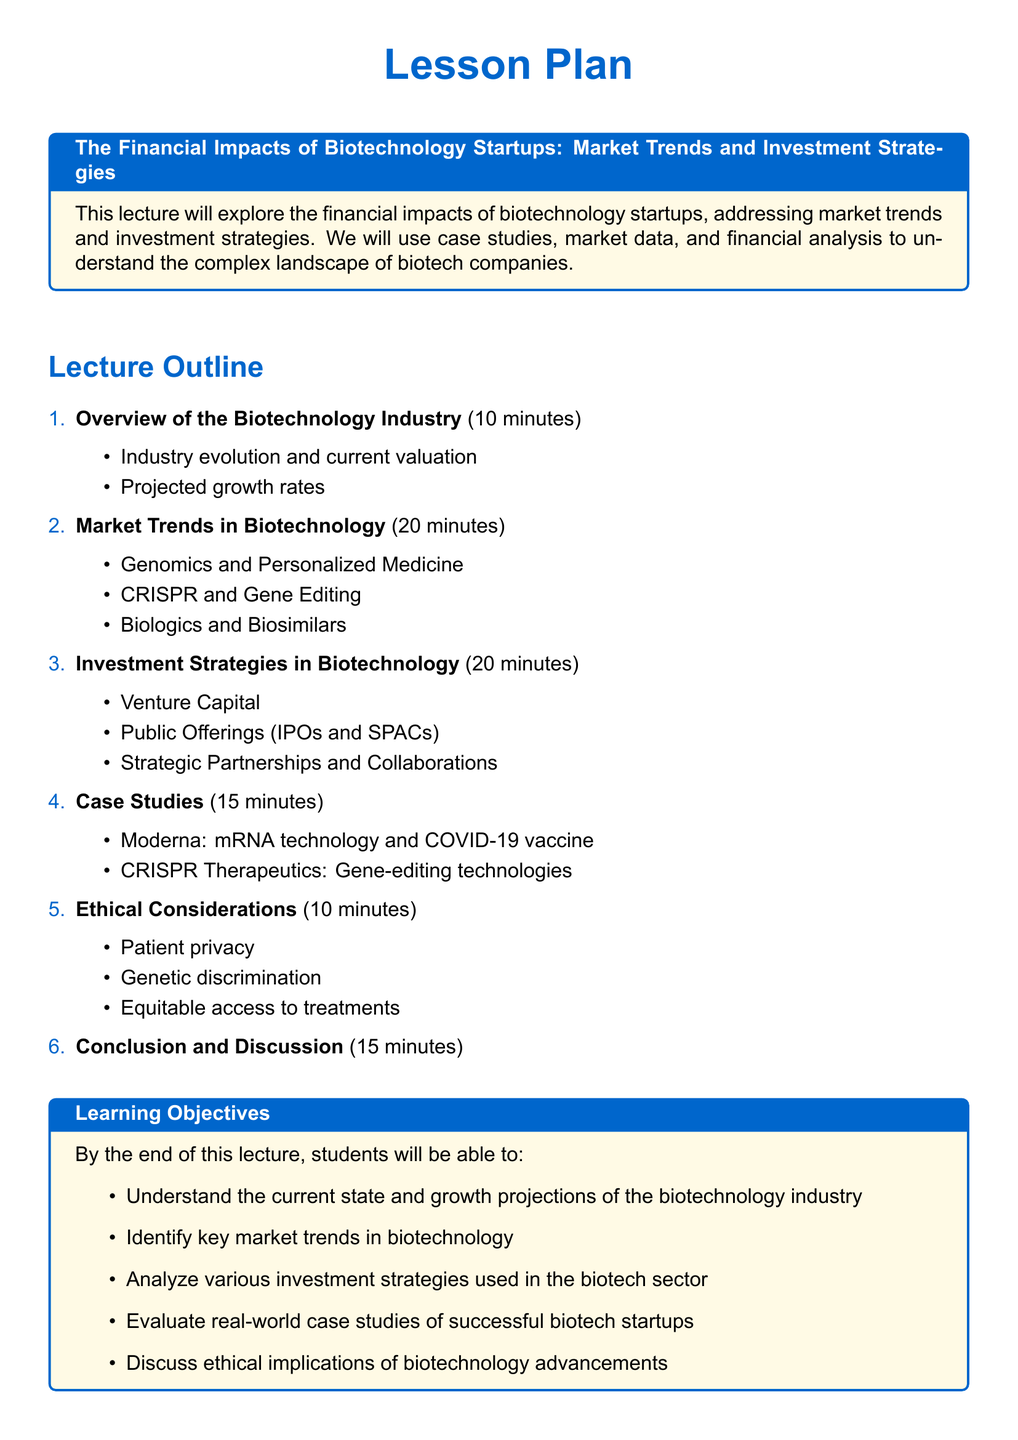What is the total duration of the lecture? The total duration is calculated by adding all the time allocations for each section of the lecture, which totals 90 minutes.
Answer: 90 minutes What is one of the key market trends discussed in the lecture? The lecture outlines several key market trends, one of which is personalized medicine.
Answer: Personalized Medicine Which company is highlighted for its mRNA technology? The case study focuses on Moderna's use of mRNA technology for the COVID-19 vaccine.
Answer: Moderna What is the main ethical consideration addressed in the lecture? The lecture addresses several ethical considerations; one significant aspect is patient privacy.
Answer: Patient privacy How many minutes are dedicated to investment strategies? The investment strategies section is allotted 20 minutes in the lecture outline.
Answer: 20 minutes What is one investment strategy mentioned in the document? The document mentions several investment strategies, including venture capital.
Answer: Venture Capital What is the projected growth aspect discussed in the overview section? The overview discusses projected growth rates within the biotechnology industry.
Answer: Projected growth rates What is one required reading for the lecture? The required readings list includes the "Company Overview" from Illumina, Inc.
Answer: Company Overview How long is the conclusion and discussion segment? The conclusion and discussion segment is set for 15 minutes.
Answer: 15 minutes 